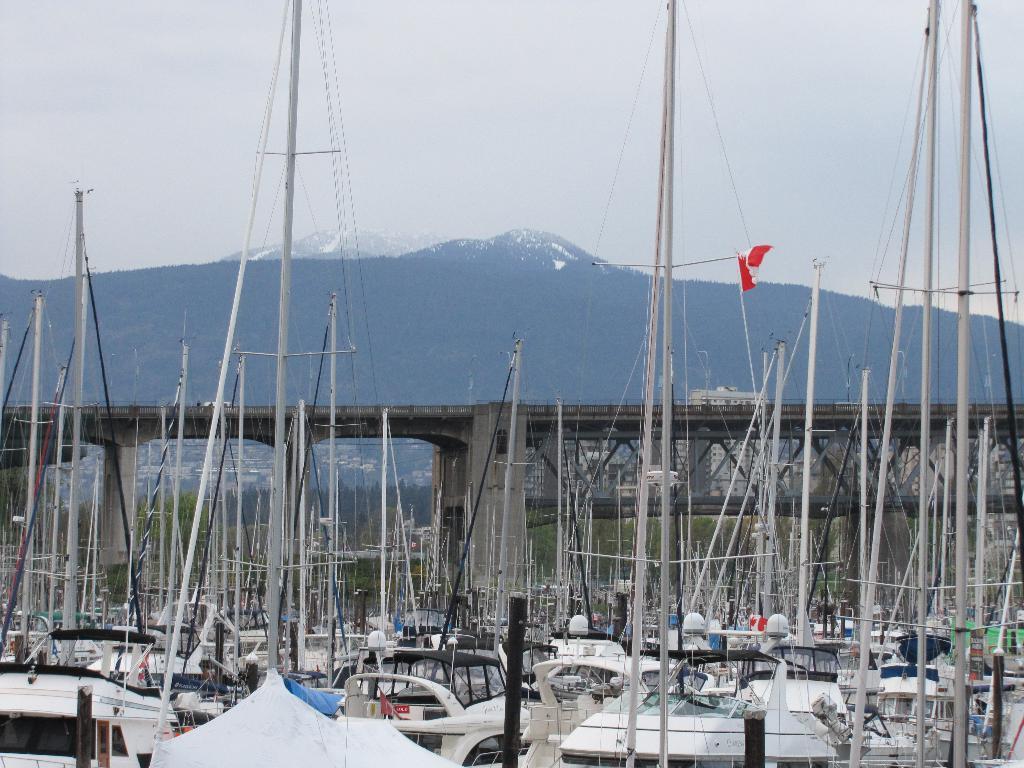Describe this image in one or two sentences. In this image I see number of boats and I see the bridge over here and I see a flag which is of white and red in color. In the background I see the mountains and the sky. 